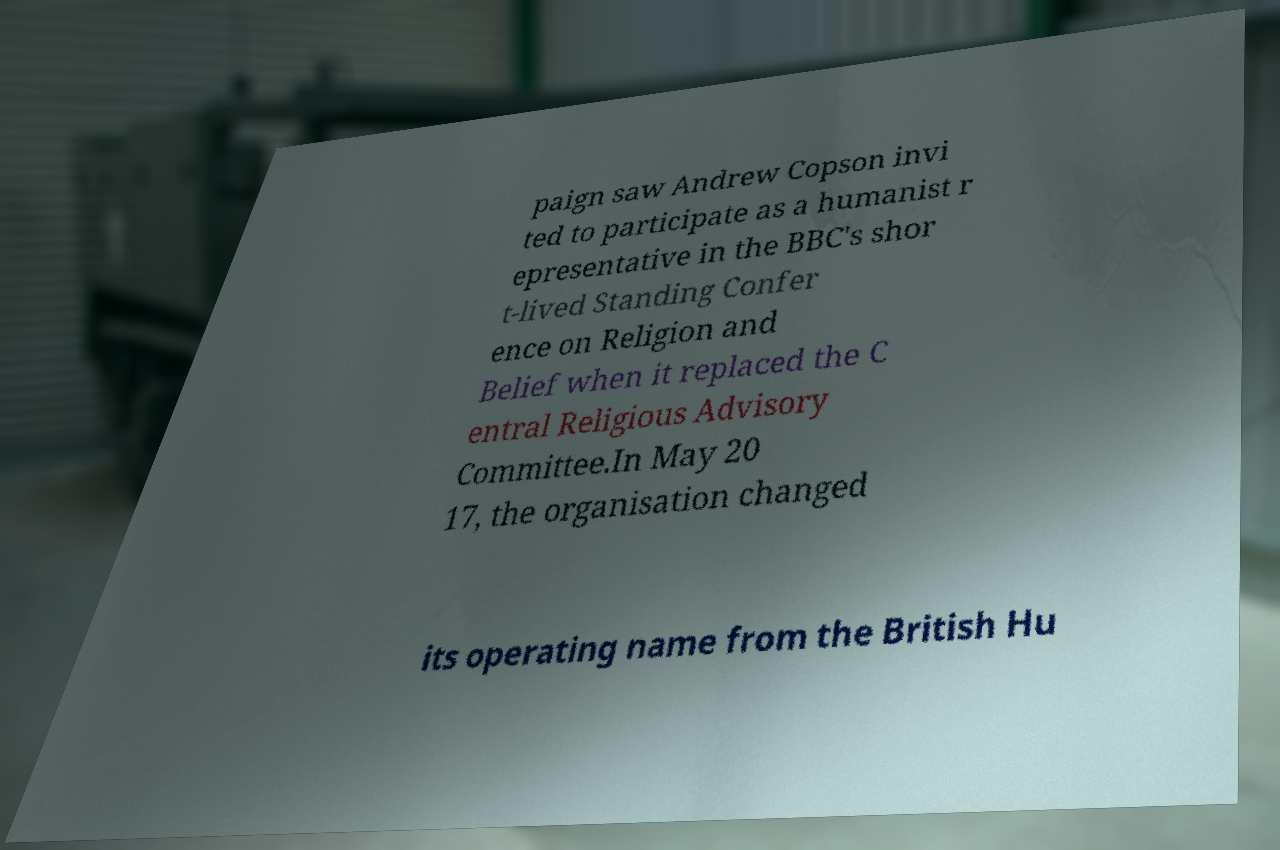There's text embedded in this image that I need extracted. Can you transcribe it verbatim? paign saw Andrew Copson invi ted to participate as a humanist r epresentative in the BBC's shor t-lived Standing Confer ence on Religion and Belief when it replaced the C entral Religious Advisory Committee.In May 20 17, the organisation changed its operating name from the British Hu 